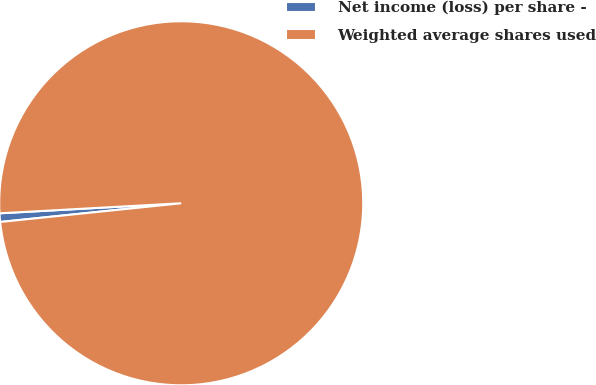<chart> <loc_0><loc_0><loc_500><loc_500><pie_chart><fcel>Net income (loss) per share -<fcel>Weighted average shares used<nl><fcel>0.76%<fcel>99.24%<nl></chart> 